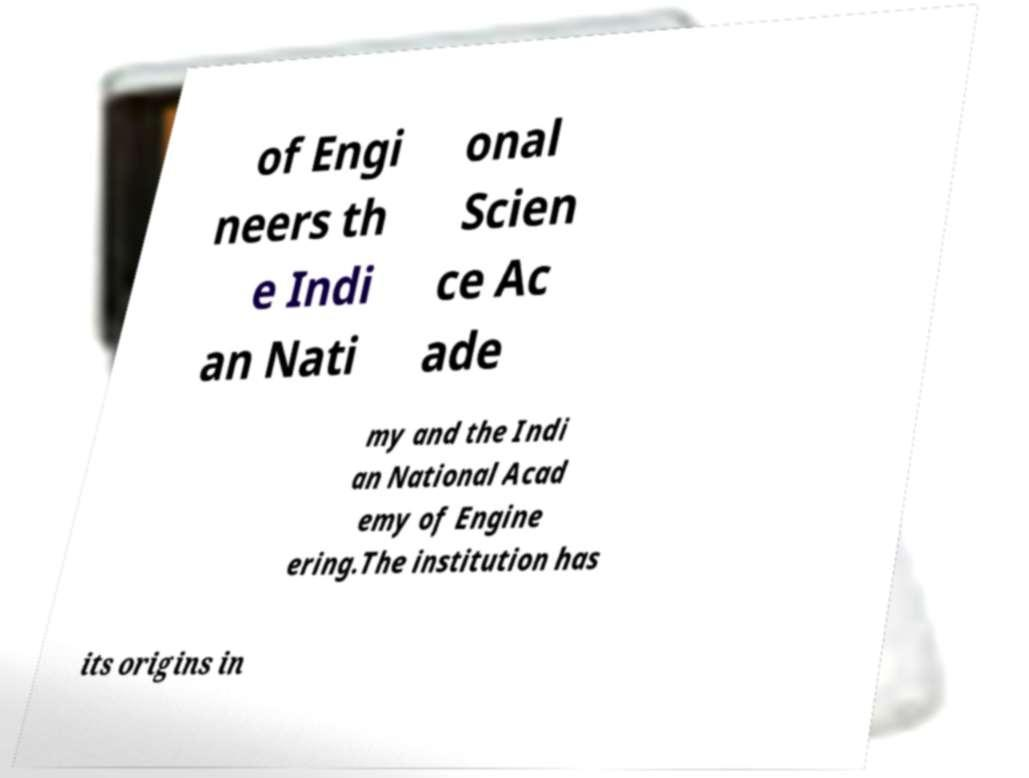Can you accurately transcribe the text from the provided image for me? of Engi neers th e Indi an Nati onal Scien ce Ac ade my and the Indi an National Acad emy of Engine ering.The institution has its origins in 